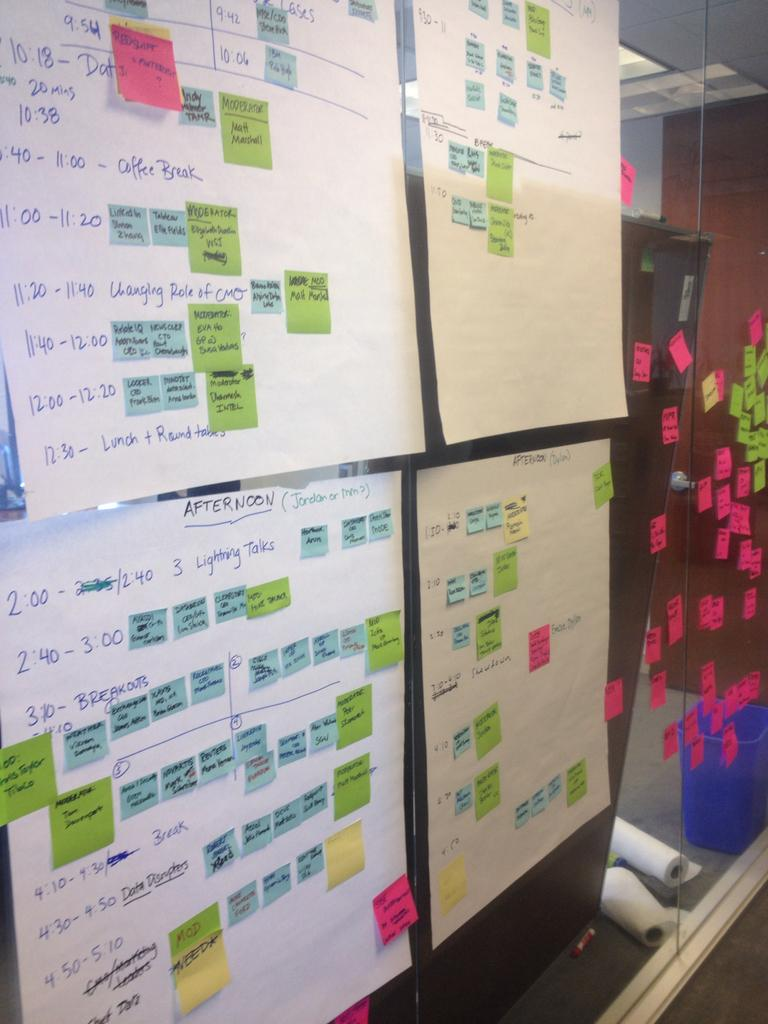<image>
Relay a brief, clear account of the picture shown. Four boards on display with the time 9:54 one the top left one. 